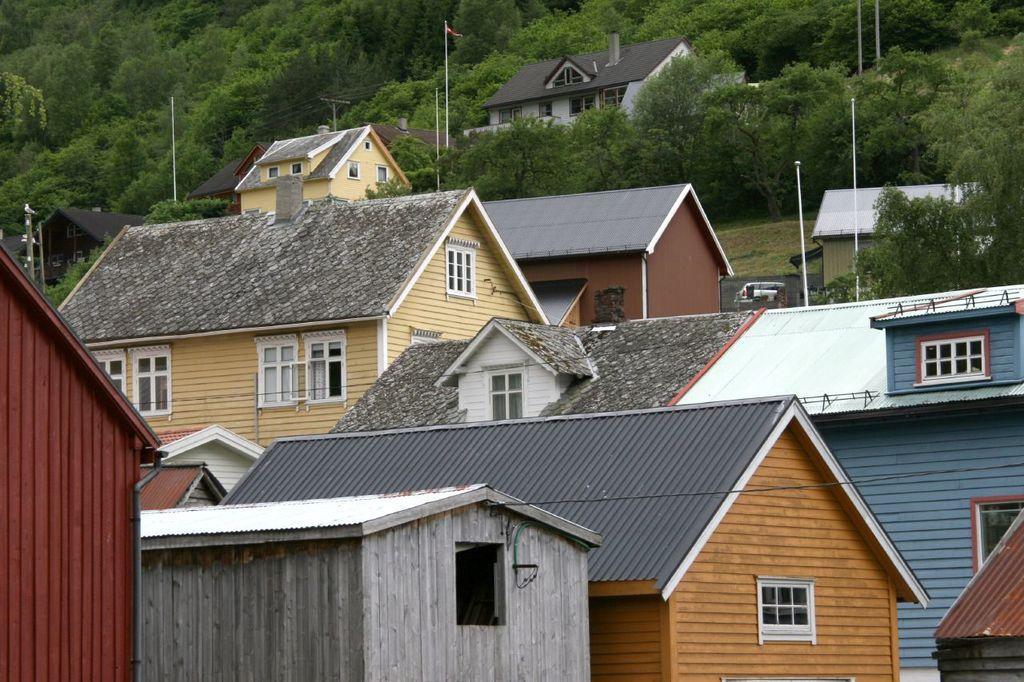What type of structures are located in the front of the image? There are buildings in the front of the image. What can be seen in the background of the image? In the background of the image, there are poles, wires, more buildings, and trees. Can you describe the arrangement of the buildings in the image? There are buildings in both the front and background of the image. What type of vegetation is visible in the background? Trees are visible in the background of the image. How does the queen use the poles in the image? There is no queen present in the image, and therefore no such interaction can be observed. Can you describe the kicking motion of the trees in the image? There is no kicking motion present in the image; the trees are stationary. 